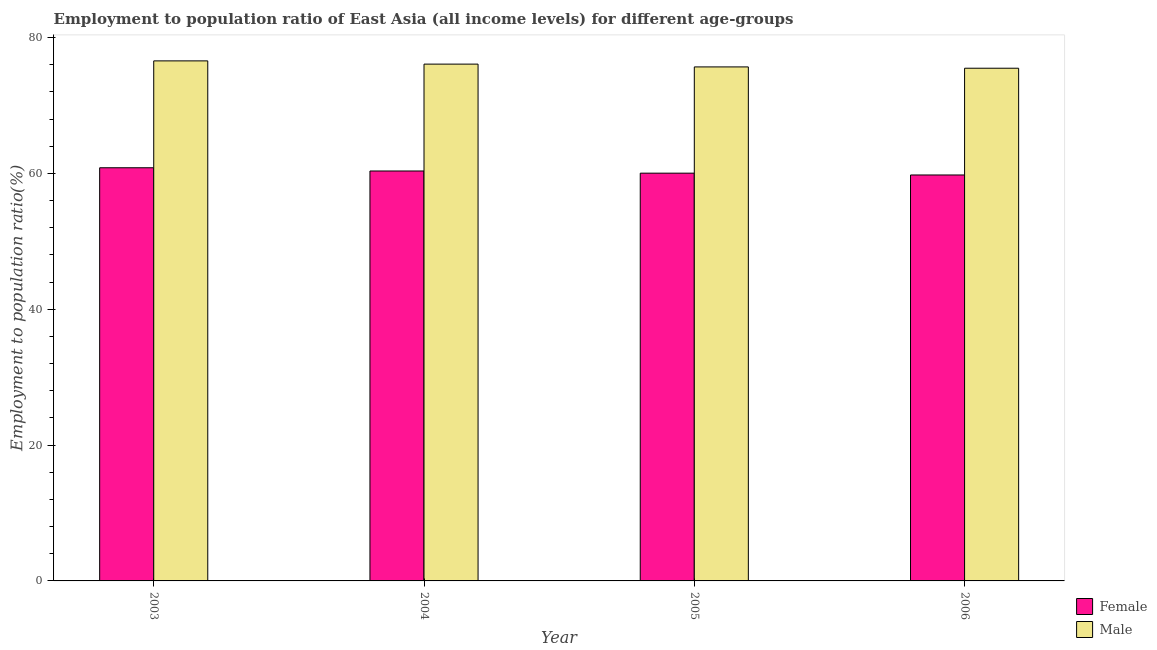Are the number of bars per tick equal to the number of legend labels?
Give a very brief answer. Yes. Are the number of bars on each tick of the X-axis equal?
Keep it short and to the point. Yes. What is the label of the 4th group of bars from the left?
Provide a succinct answer. 2006. What is the employment to population ratio(female) in 2003?
Offer a terse response. 60.84. Across all years, what is the maximum employment to population ratio(male)?
Make the answer very short. 76.58. Across all years, what is the minimum employment to population ratio(male)?
Make the answer very short. 75.49. In which year was the employment to population ratio(male) maximum?
Offer a terse response. 2003. In which year was the employment to population ratio(female) minimum?
Give a very brief answer. 2006. What is the total employment to population ratio(female) in the graph?
Provide a short and direct response. 241.01. What is the difference between the employment to population ratio(male) in 2005 and that in 2006?
Provide a short and direct response. 0.19. What is the difference between the employment to population ratio(female) in 2005 and the employment to population ratio(male) in 2006?
Give a very brief answer. 0.27. What is the average employment to population ratio(male) per year?
Offer a terse response. 75.96. What is the ratio of the employment to population ratio(female) in 2004 to that in 2005?
Make the answer very short. 1.01. What is the difference between the highest and the second highest employment to population ratio(female)?
Your answer should be very brief. 0.48. What is the difference between the highest and the lowest employment to population ratio(female)?
Give a very brief answer. 1.06. In how many years, is the employment to population ratio(female) greater than the average employment to population ratio(female) taken over all years?
Your answer should be compact. 2. Is the sum of the employment to population ratio(female) in 2003 and 2004 greater than the maximum employment to population ratio(male) across all years?
Ensure brevity in your answer.  Yes. What does the 1st bar from the right in 2003 represents?
Ensure brevity in your answer.  Male. How many years are there in the graph?
Give a very brief answer. 4. What is the difference between two consecutive major ticks on the Y-axis?
Your answer should be very brief. 20. Are the values on the major ticks of Y-axis written in scientific E-notation?
Give a very brief answer. No. Does the graph contain any zero values?
Your response must be concise. No. Where does the legend appear in the graph?
Provide a succinct answer. Bottom right. What is the title of the graph?
Ensure brevity in your answer.  Employment to population ratio of East Asia (all income levels) for different age-groups. What is the Employment to population ratio(%) of Female in 2003?
Make the answer very short. 60.84. What is the Employment to population ratio(%) of Male in 2003?
Give a very brief answer. 76.58. What is the Employment to population ratio(%) of Female in 2004?
Keep it short and to the point. 60.36. What is the Employment to population ratio(%) in Male in 2004?
Your answer should be very brief. 76.1. What is the Employment to population ratio(%) of Female in 2005?
Your response must be concise. 60.04. What is the Employment to population ratio(%) in Male in 2005?
Make the answer very short. 75.69. What is the Employment to population ratio(%) of Female in 2006?
Your answer should be compact. 59.77. What is the Employment to population ratio(%) of Male in 2006?
Provide a succinct answer. 75.49. Across all years, what is the maximum Employment to population ratio(%) of Female?
Ensure brevity in your answer.  60.84. Across all years, what is the maximum Employment to population ratio(%) of Male?
Your answer should be compact. 76.58. Across all years, what is the minimum Employment to population ratio(%) in Female?
Your answer should be compact. 59.77. Across all years, what is the minimum Employment to population ratio(%) in Male?
Offer a very short reply. 75.49. What is the total Employment to population ratio(%) in Female in the graph?
Offer a very short reply. 241.01. What is the total Employment to population ratio(%) of Male in the graph?
Give a very brief answer. 303.85. What is the difference between the Employment to population ratio(%) in Female in 2003 and that in 2004?
Provide a succinct answer. 0.48. What is the difference between the Employment to population ratio(%) of Male in 2003 and that in 2004?
Make the answer very short. 0.48. What is the difference between the Employment to population ratio(%) of Female in 2003 and that in 2005?
Offer a terse response. 0.8. What is the difference between the Employment to population ratio(%) in Male in 2003 and that in 2005?
Offer a very short reply. 0.89. What is the difference between the Employment to population ratio(%) in Female in 2003 and that in 2006?
Offer a terse response. 1.06. What is the difference between the Employment to population ratio(%) in Male in 2003 and that in 2006?
Give a very brief answer. 1.08. What is the difference between the Employment to population ratio(%) of Female in 2004 and that in 2005?
Offer a very short reply. 0.32. What is the difference between the Employment to population ratio(%) of Male in 2004 and that in 2005?
Your answer should be compact. 0.41. What is the difference between the Employment to population ratio(%) of Female in 2004 and that in 2006?
Your response must be concise. 0.59. What is the difference between the Employment to population ratio(%) of Male in 2004 and that in 2006?
Ensure brevity in your answer.  0.6. What is the difference between the Employment to population ratio(%) of Female in 2005 and that in 2006?
Provide a succinct answer. 0.27. What is the difference between the Employment to population ratio(%) in Male in 2005 and that in 2006?
Ensure brevity in your answer.  0.19. What is the difference between the Employment to population ratio(%) of Female in 2003 and the Employment to population ratio(%) of Male in 2004?
Your answer should be compact. -15.26. What is the difference between the Employment to population ratio(%) in Female in 2003 and the Employment to population ratio(%) in Male in 2005?
Give a very brief answer. -14.85. What is the difference between the Employment to population ratio(%) of Female in 2003 and the Employment to population ratio(%) of Male in 2006?
Your answer should be very brief. -14.66. What is the difference between the Employment to population ratio(%) in Female in 2004 and the Employment to population ratio(%) in Male in 2005?
Your response must be concise. -15.32. What is the difference between the Employment to population ratio(%) in Female in 2004 and the Employment to population ratio(%) in Male in 2006?
Your answer should be very brief. -15.13. What is the difference between the Employment to population ratio(%) of Female in 2005 and the Employment to population ratio(%) of Male in 2006?
Offer a very short reply. -15.45. What is the average Employment to population ratio(%) in Female per year?
Your response must be concise. 60.25. What is the average Employment to population ratio(%) of Male per year?
Provide a succinct answer. 75.96. In the year 2003, what is the difference between the Employment to population ratio(%) of Female and Employment to population ratio(%) of Male?
Give a very brief answer. -15.74. In the year 2004, what is the difference between the Employment to population ratio(%) of Female and Employment to population ratio(%) of Male?
Offer a terse response. -15.74. In the year 2005, what is the difference between the Employment to population ratio(%) in Female and Employment to population ratio(%) in Male?
Keep it short and to the point. -15.64. In the year 2006, what is the difference between the Employment to population ratio(%) in Female and Employment to population ratio(%) in Male?
Provide a succinct answer. -15.72. What is the ratio of the Employment to population ratio(%) of Female in 2003 to that in 2004?
Offer a very short reply. 1.01. What is the ratio of the Employment to population ratio(%) in Male in 2003 to that in 2004?
Provide a succinct answer. 1.01. What is the ratio of the Employment to population ratio(%) in Female in 2003 to that in 2005?
Offer a very short reply. 1.01. What is the ratio of the Employment to population ratio(%) in Male in 2003 to that in 2005?
Your answer should be very brief. 1.01. What is the ratio of the Employment to population ratio(%) in Female in 2003 to that in 2006?
Provide a short and direct response. 1.02. What is the ratio of the Employment to population ratio(%) of Male in 2003 to that in 2006?
Make the answer very short. 1.01. What is the ratio of the Employment to population ratio(%) of Male in 2004 to that in 2005?
Provide a short and direct response. 1.01. What is the ratio of the Employment to population ratio(%) of Female in 2004 to that in 2006?
Provide a succinct answer. 1.01. What is the ratio of the Employment to population ratio(%) in Female in 2005 to that in 2006?
Your answer should be very brief. 1. What is the difference between the highest and the second highest Employment to population ratio(%) in Female?
Keep it short and to the point. 0.48. What is the difference between the highest and the second highest Employment to population ratio(%) in Male?
Keep it short and to the point. 0.48. What is the difference between the highest and the lowest Employment to population ratio(%) of Female?
Make the answer very short. 1.06. What is the difference between the highest and the lowest Employment to population ratio(%) of Male?
Ensure brevity in your answer.  1.08. 